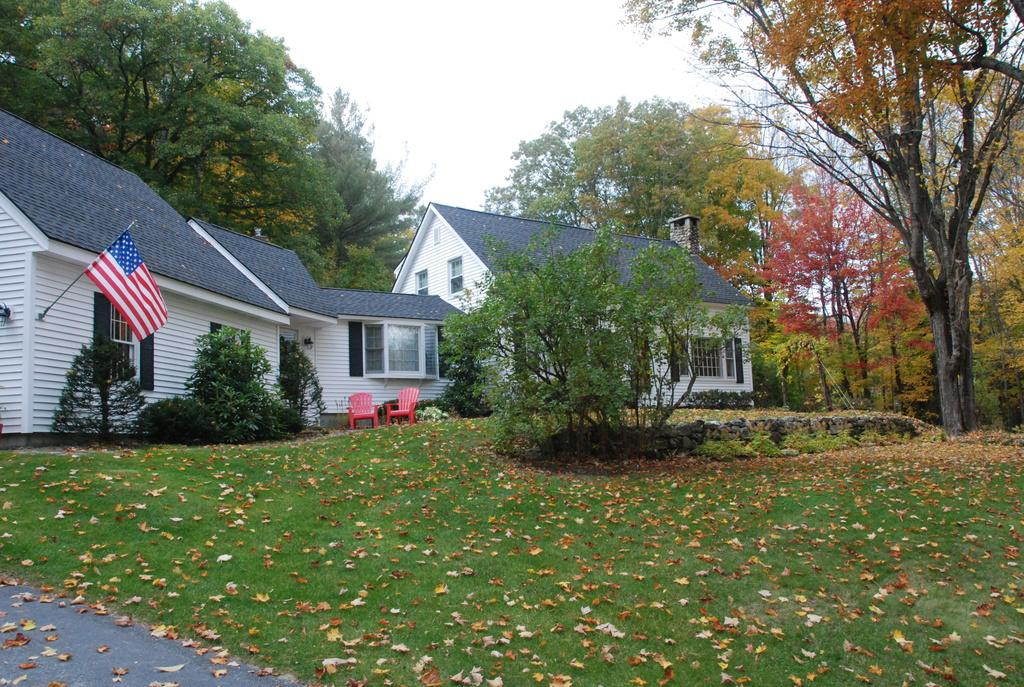What type of vegetation is present on the ground in the image? There is grass on the ground in the image. What structures can be seen in the middle of the image? There are houses in the middle of the image. What type of plant is on the right side of the image? There is a tree on the right side of the image. Where is the aunt sitting with a tray and hook in the image? There is no aunt, tray, or hook present in the image. 